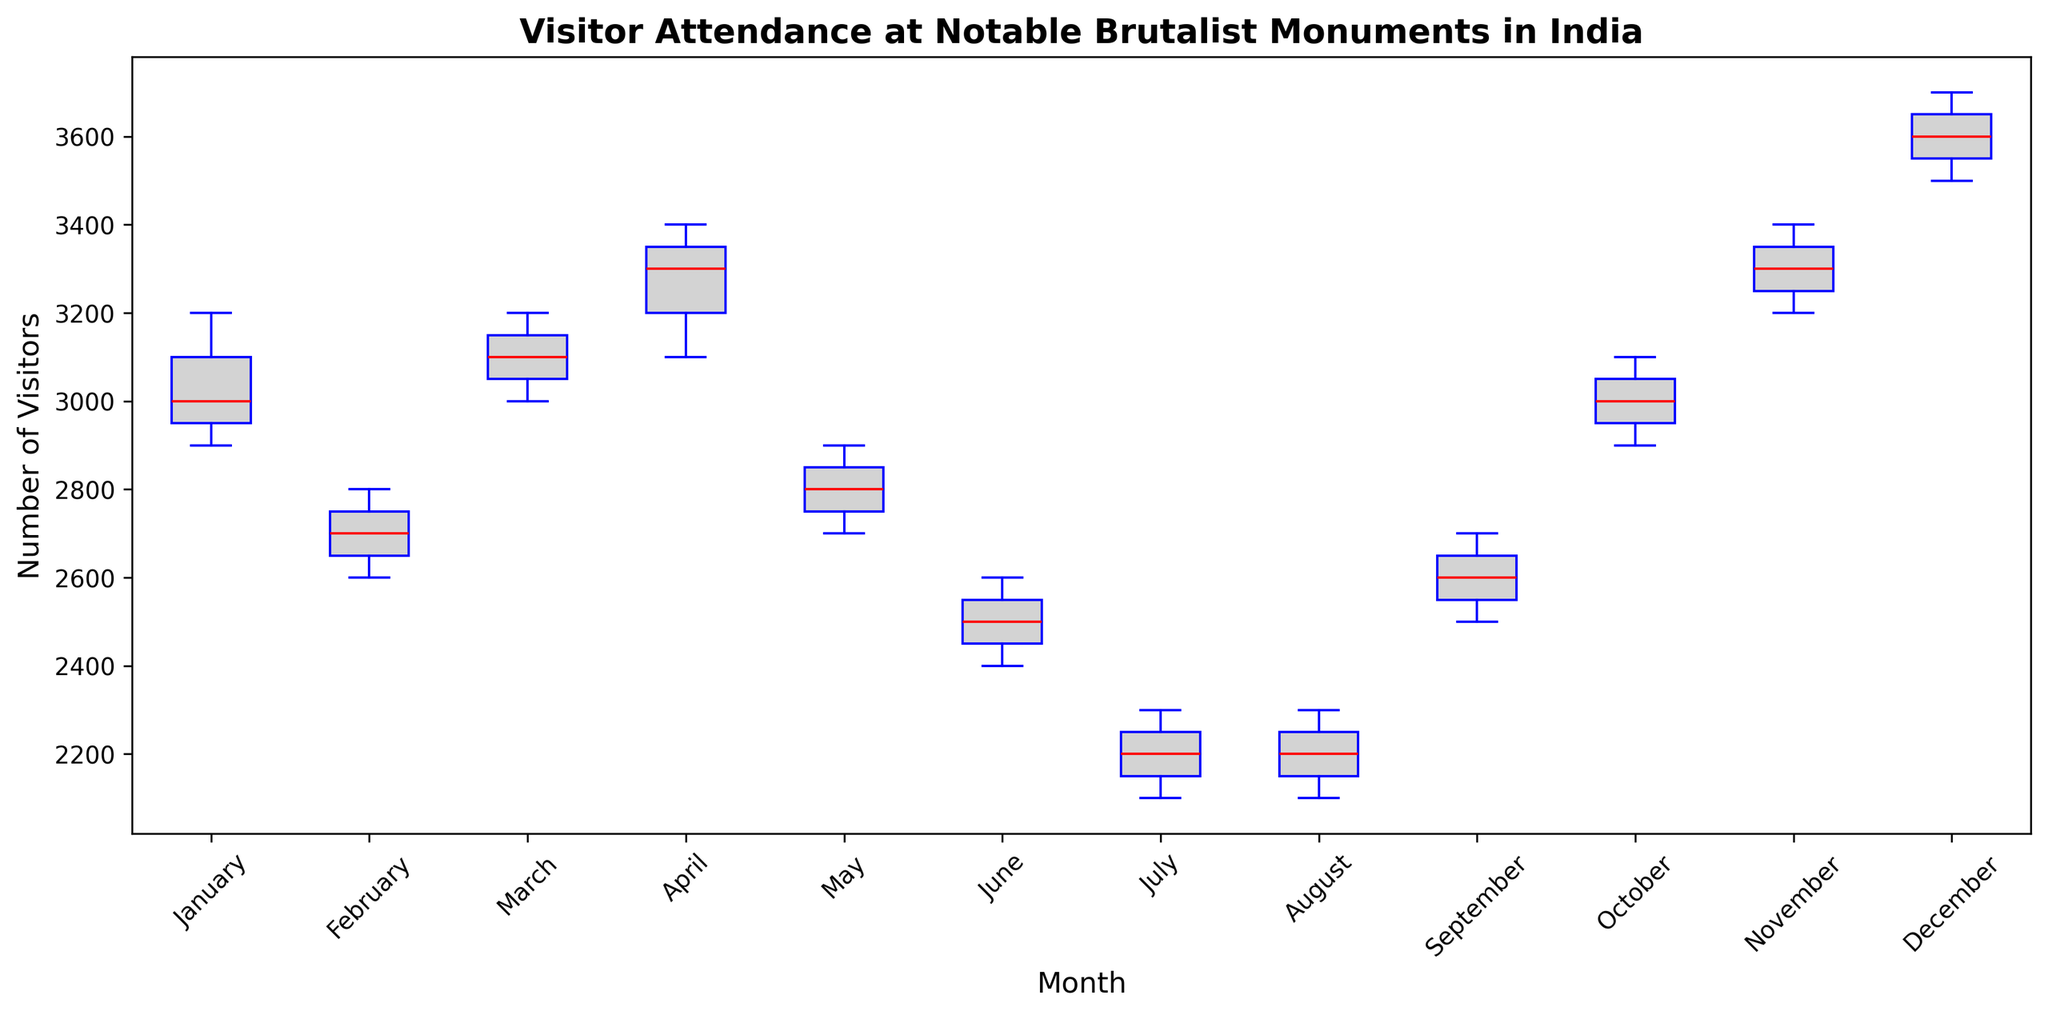What's the median visitor attendance in March? The box plot's central line within the box represents the median value for visitor attendance in March. By observing the box plot for March, the median number of visitors is indicated.
Answer: 3100 Which month has the lowest median visitor attendance? To find the month with the lowest median visitor attendance, we need to look for the month where the central line in the box is the lowest on the y-axis. Upon examination, July has the lowest median visitor attendance.
Answer: July Compare the interquartile ranges (IQR) of January and June. Which is larger? The IQR is the range between the 25th percentile (bottom of the box) and the 75th percentile (top of the box). In January, the IQR is larger because the box itself is taller compared to that of June, indicating a wider range of visitor attendance.
Answer: January During which month(s) is the median attendance closest to 3000 visitors? The month(s) where the central line in the box is closest to the 3000 mark on the y-axis represent the median closest to 3000. Upon examination, both October and March have medians very close to 3000 visitors.
Answer: March, October How does the distribution of visitor attendance in December compare to that in August? Comparing the December and August box plots, December has a higher median, higher upper quartile, taller box indicating wider variation, and higher overall visitor attendance, while August shows lower values across all metrics.
Answer: December has higher attendance with wider variation Which month shows the most consistent visitor attendance based on the box plot? Consistency in attendance can be seen through a smaller IQR, shorter whiskers, and fewer outliers. By examining the box plots, June shows the most consistent visitor attendance as it has a smaller IQR and shorter whiskers.
Answer: June What's the difference between the medians of February and November? Find the medians of February (the central line of February's box) and November. Subtract the February median from the November median. February’s median is around 2700 and November’s is around 3300.
Answer: 3300 - 2700 = 600 Which month(s) show visitor attendance values above 3500? Attendance above 3500 is indicated by points or whiskers extending above the 3500 mark on the y-axis. December clearly shows visitor attendance values above 3500 as visible outliers or upper whiskers.
Answer: December 